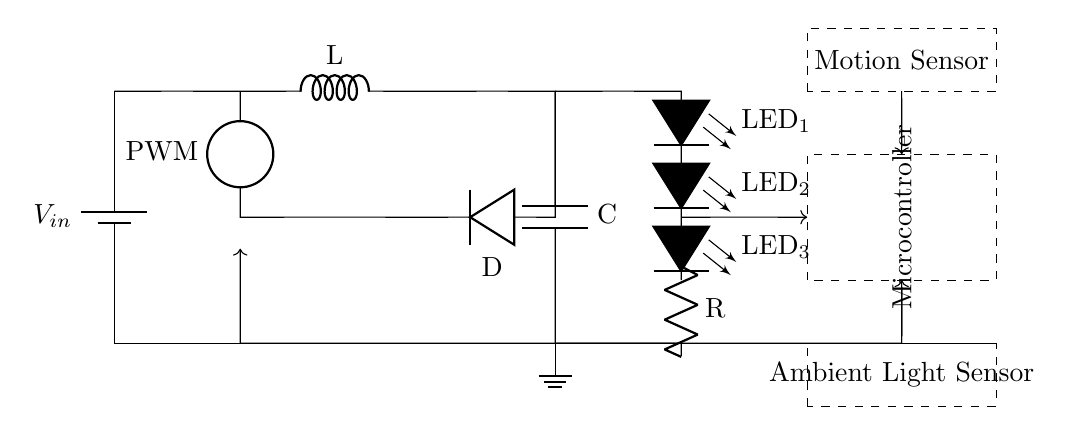What is the input voltage source of the circuit? The circuit diagram indicates a battery labeled V_in, which represents the input voltage source for the entire system.
Answer: V_in What does the microcontroller do in this circuit? The microcontroller controls the PWM (Pulse Width Modulation) signal to adjust the brightness of the LED string based on input from the motion and ambient light sensors.
Answer: PWM control Which component acts as a light sensor? The ambient light sensor is the component responsible for detecting the levels of surrounding light to adjust the LED brightness accordingly.
Answer: Ambient light sensor What type of converter is being used? The circuit uses a buck converter, which steps down the voltage from the battery to the required level for the LEDs.
Answer: Buck converter How many LEDs are in the LED string? There are three LEDs in the LED string connected in series to provide illumination in the hotel room.
Answer: Three What is the purpose of the motion sensor in this circuit? The motion sensor detects movement in the room, allowing the microcontroller to turn on the LED lighting when someone is present, promoting energy efficiency.
Answer: Detects movement What is the role of the capacitor in this circuit? The capacitor smooths out voltage fluctuations and provides stable power to the LED string, enhancing performance and efficiency.
Answer: Voltage stabilization 